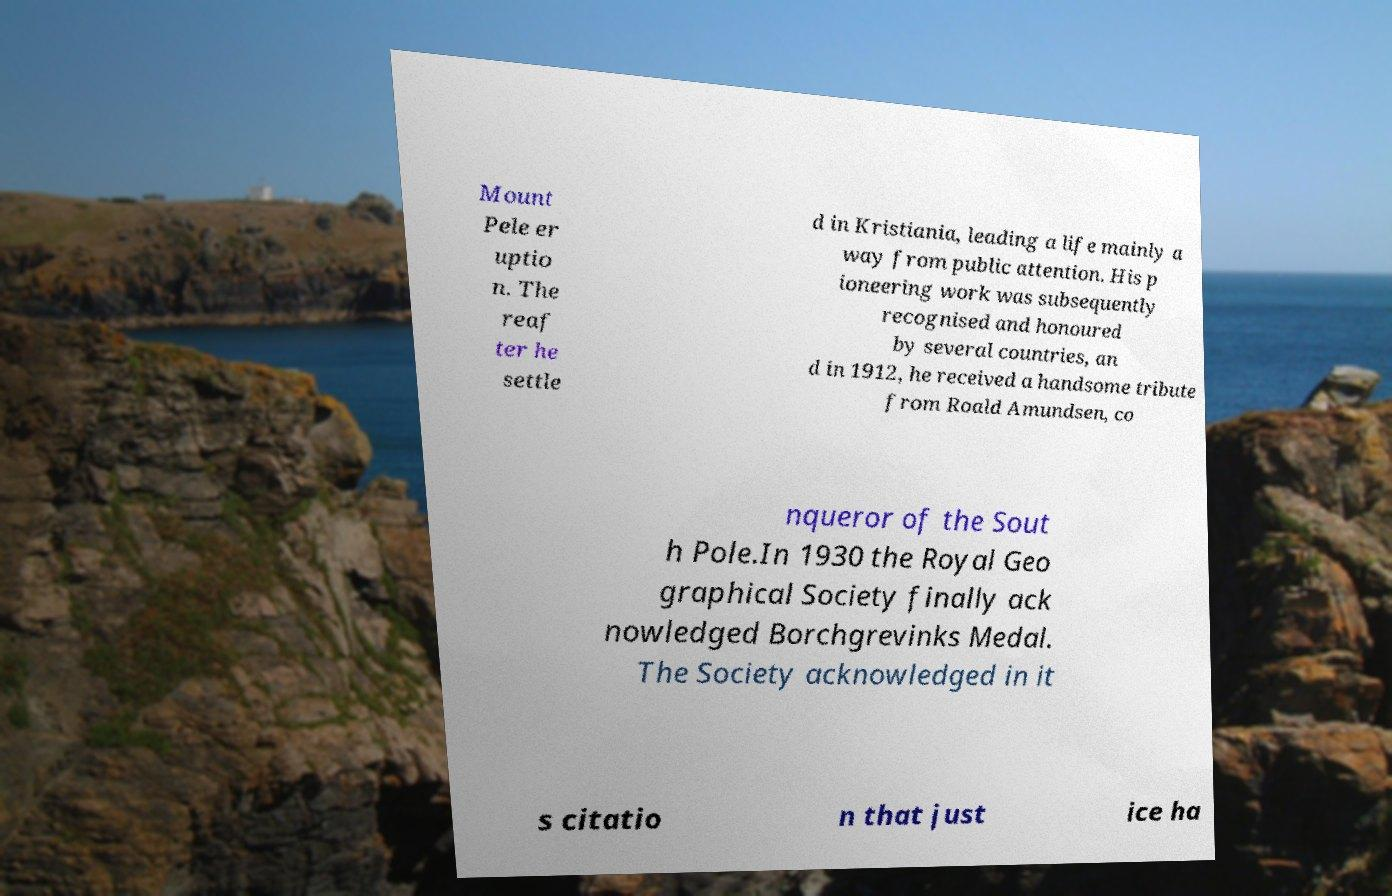Can you accurately transcribe the text from the provided image for me? Mount Pele er uptio n. The reaf ter he settle d in Kristiania, leading a life mainly a way from public attention. His p ioneering work was subsequently recognised and honoured by several countries, an d in 1912, he received a handsome tribute from Roald Amundsen, co nqueror of the Sout h Pole.In 1930 the Royal Geo graphical Society finally ack nowledged Borchgrevinks Medal. The Society acknowledged in it s citatio n that just ice ha 